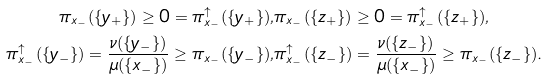<formula> <loc_0><loc_0><loc_500><loc_500>\pi _ { x _ { - } } ( \{ y _ { + } \} ) \geq 0 = \pi _ { x _ { - } } ^ { \uparrow } ( \{ y _ { + } \} ) , & \pi _ { x _ { - } } ( \{ z _ { + } \} ) \geq 0 = \pi _ { x _ { - } } ^ { \uparrow } ( \{ z _ { + } \} ) , \\ \pi _ { x _ { - } } ^ { \uparrow } ( \{ y _ { - } \} ) = \frac { \nu ( \{ y _ { - } \} ) } { \mu ( \{ x _ { - } \} ) } \geq \pi _ { x _ { - } } ( \{ y _ { - } \} ) , & \pi _ { x _ { - } } ^ { \uparrow } ( \{ z _ { - } \} ) = \frac { \nu ( \{ z _ { - } \} ) } { \mu ( \{ x _ { - } \} ) } \geq \pi _ { x _ { - } } ( \{ z _ { - } \} ) .</formula> 